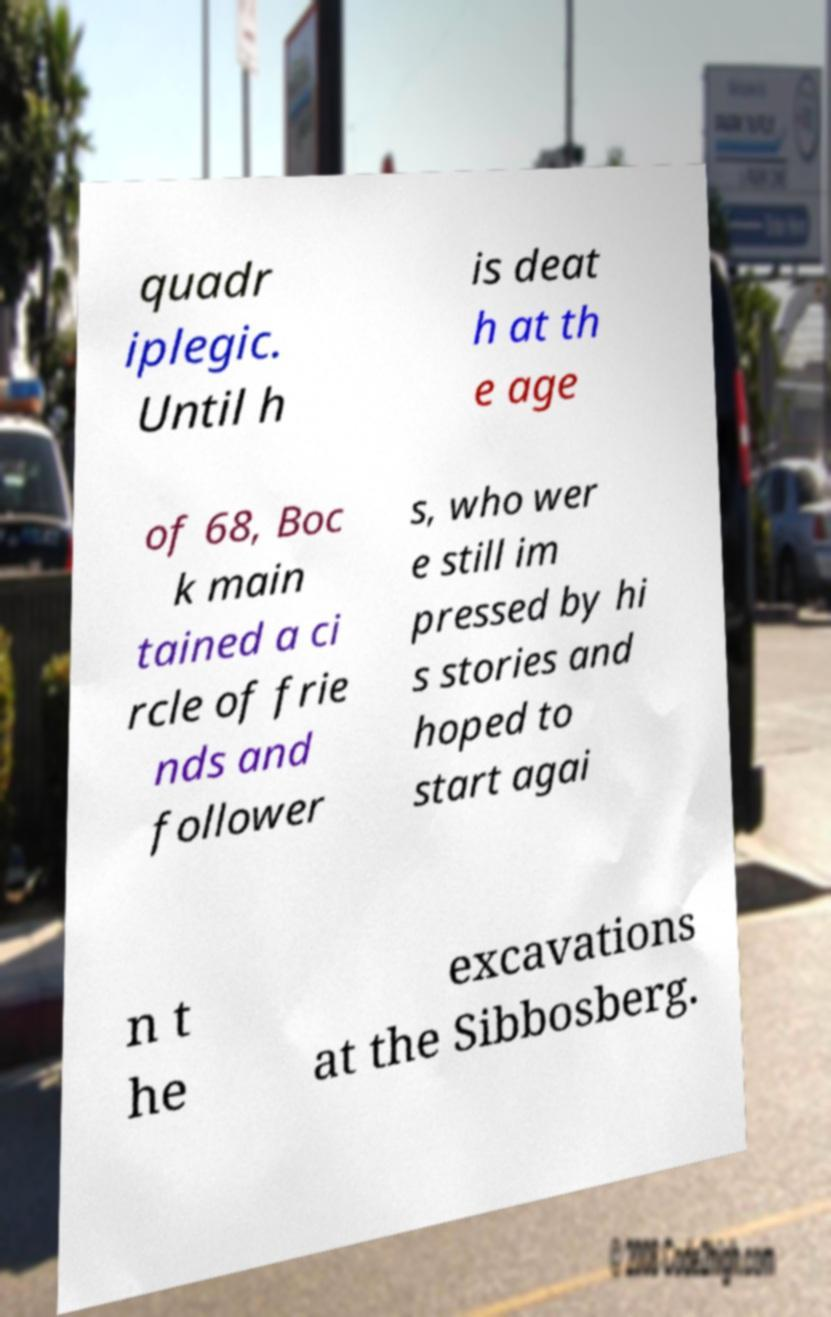Could you assist in decoding the text presented in this image and type it out clearly? quadr iplegic. Until h is deat h at th e age of 68, Boc k main tained a ci rcle of frie nds and follower s, who wer e still im pressed by hi s stories and hoped to start agai n t he excavations at the Sibbosberg. 